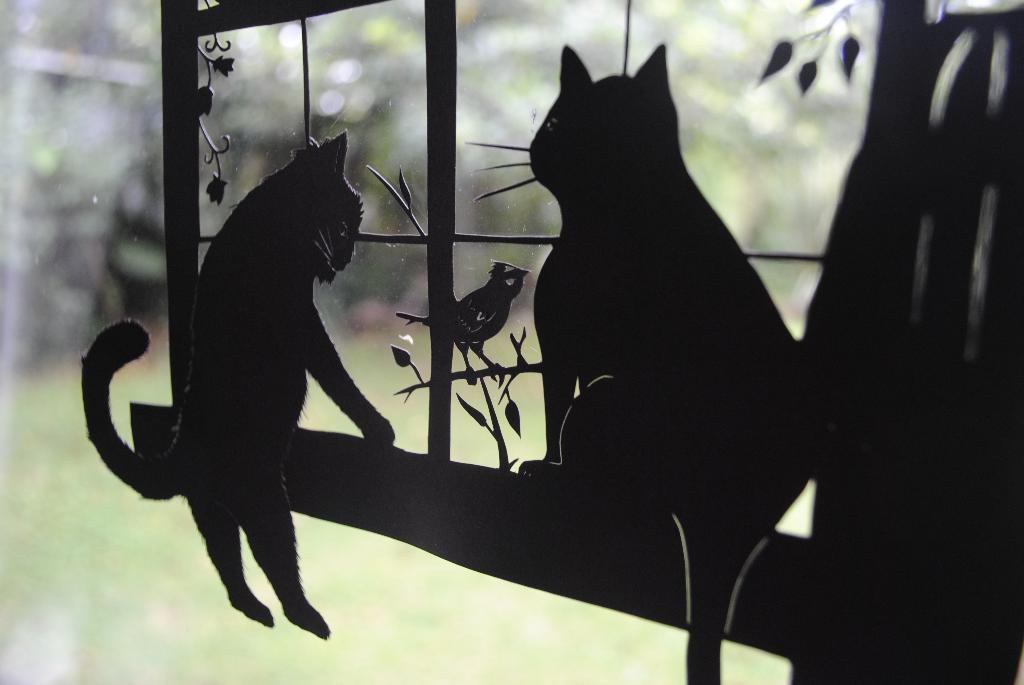Please provide a concise description of this image. In this image there is a glass door and there is a shadow of cats, bird and plant are visible and there is a blurry background. 